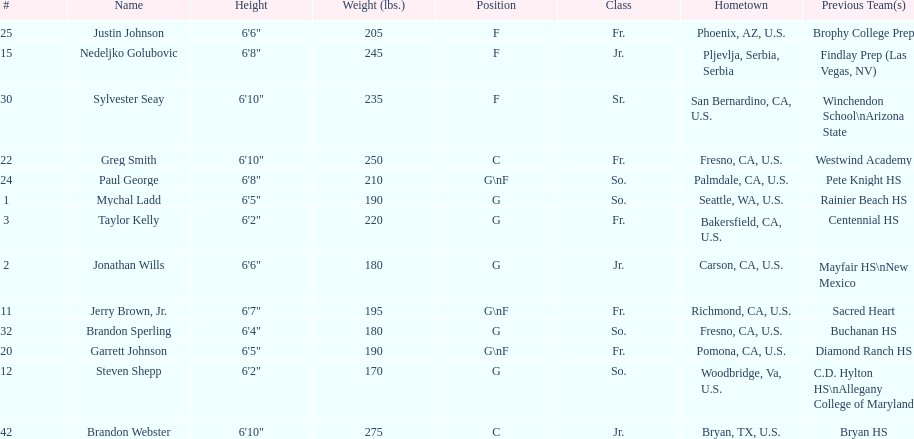Who weighs the most on the team? Brandon Webster. 